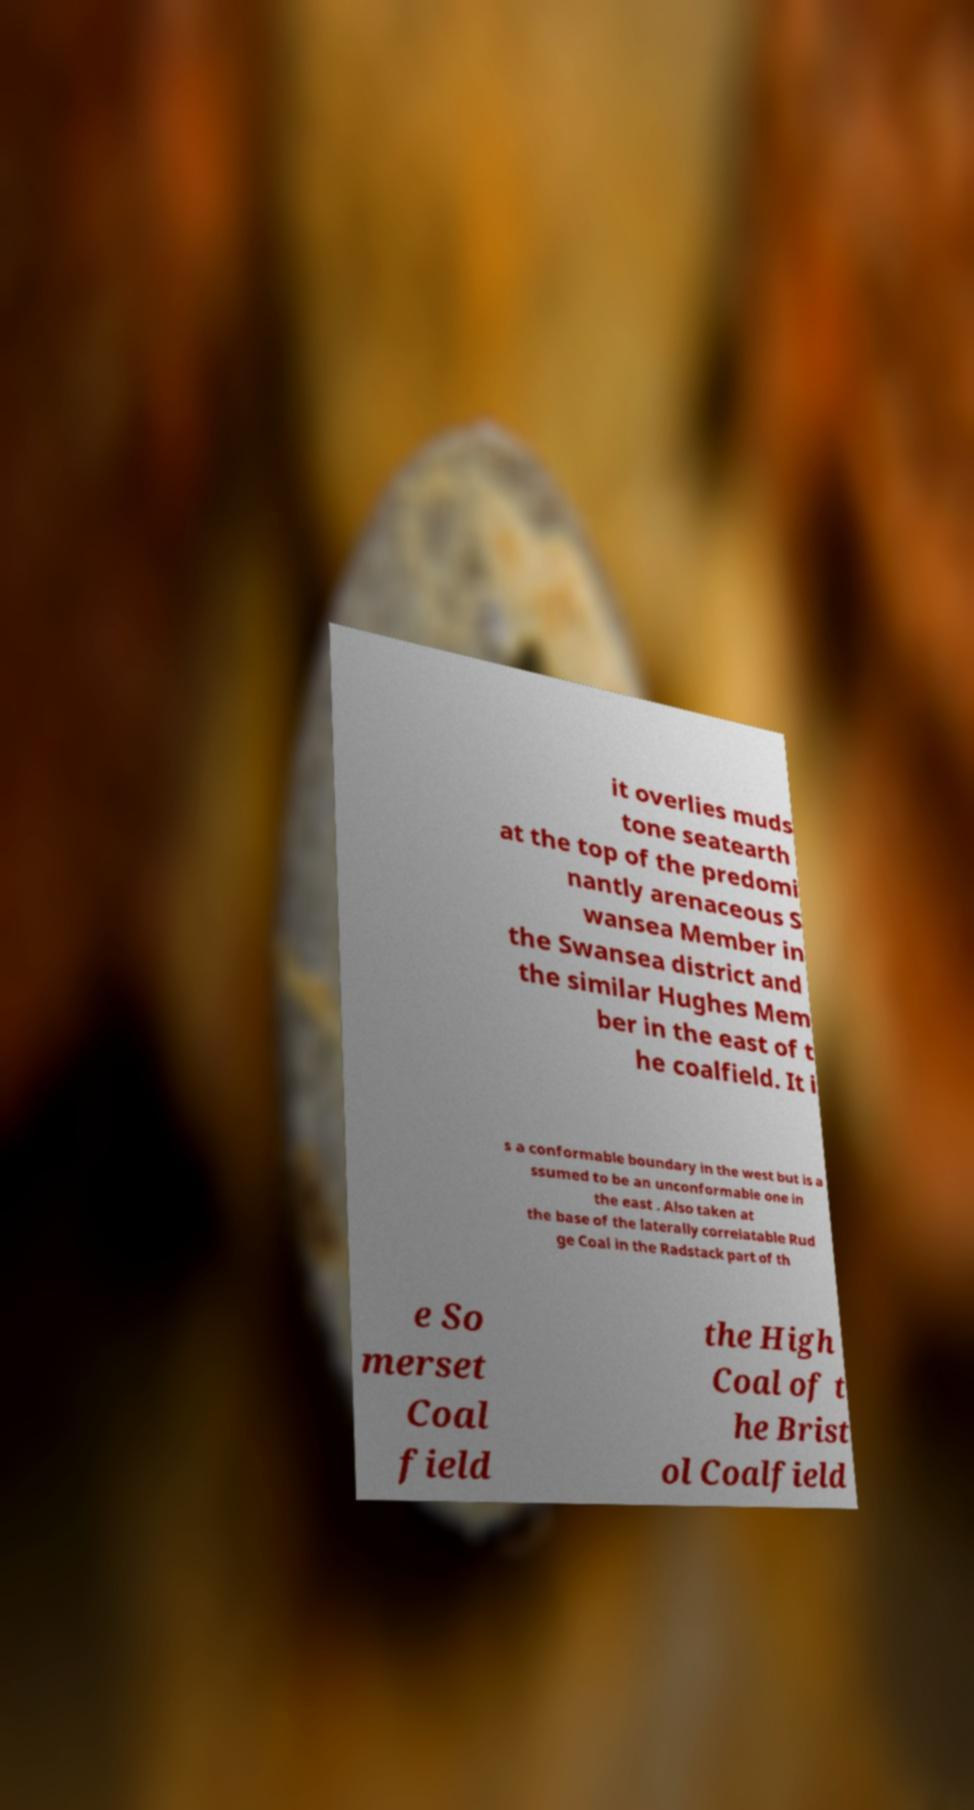Could you extract and type out the text from this image? it overlies muds tone seatearth at the top of the predomi nantly arenaceous S wansea Member in the Swansea district and the similar Hughes Mem ber in the east of t he coalfield. It i s a conformable boundary in the west but is a ssumed to be an unconformable one in the east . Also taken at the base of the laterally correlatable Rud ge Coal in the Radstack part of th e So merset Coal field the High Coal of t he Brist ol Coalfield 